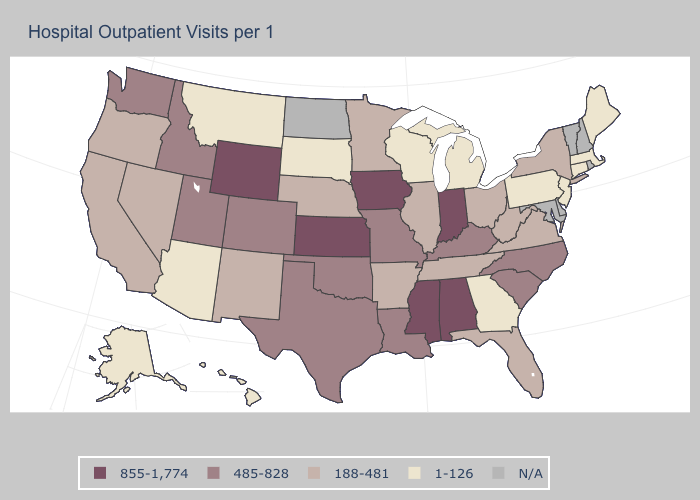Name the states that have a value in the range 188-481?
Short answer required. Arkansas, California, Florida, Illinois, Minnesota, Nebraska, Nevada, New Mexico, New York, Ohio, Oregon, Tennessee, Virginia, West Virginia. Which states have the lowest value in the USA?
Keep it brief. Alaska, Arizona, Connecticut, Georgia, Hawaii, Maine, Massachusetts, Michigan, Montana, New Jersey, Pennsylvania, South Dakota, Wisconsin. Which states hav the highest value in the West?
Give a very brief answer. Wyoming. Among the states that border New Jersey , does New York have the lowest value?
Keep it brief. No. Does the first symbol in the legend represent the smallest category?
Concise answer only. No. Name the states that have a value in the range N/A?
Be succinct. Delaware, Maryland, New Hampshire, North Dakota, Rhode Island, Vermont. What is the lowest value in the USA?
Keep it brief. 1-126. What is the lowest value in states that border Indiana?
Concise answer only. 1-126. Among the states that border Oklahoma , does Texas have the lowest value?
Concise answer only. No. How many symbols are there in the legend?
Be succinct. 5. What is the value of Georgia?
Short answer required. 1-126. Name the states that have a value in the range 188-481?
Concise answer only. Arkansas, California, Florida, Illinois, Minnesota, Nebraska, Nevada, New Mexico, New York, Ohio, Oregon, Tennessee, Virginia, West Virginia. Among the states that border Tennessee , which have the highest value?
Keep it brief. Alabama, Mississippi. Does the map have missing data?
Write a very short answer. Yes. 